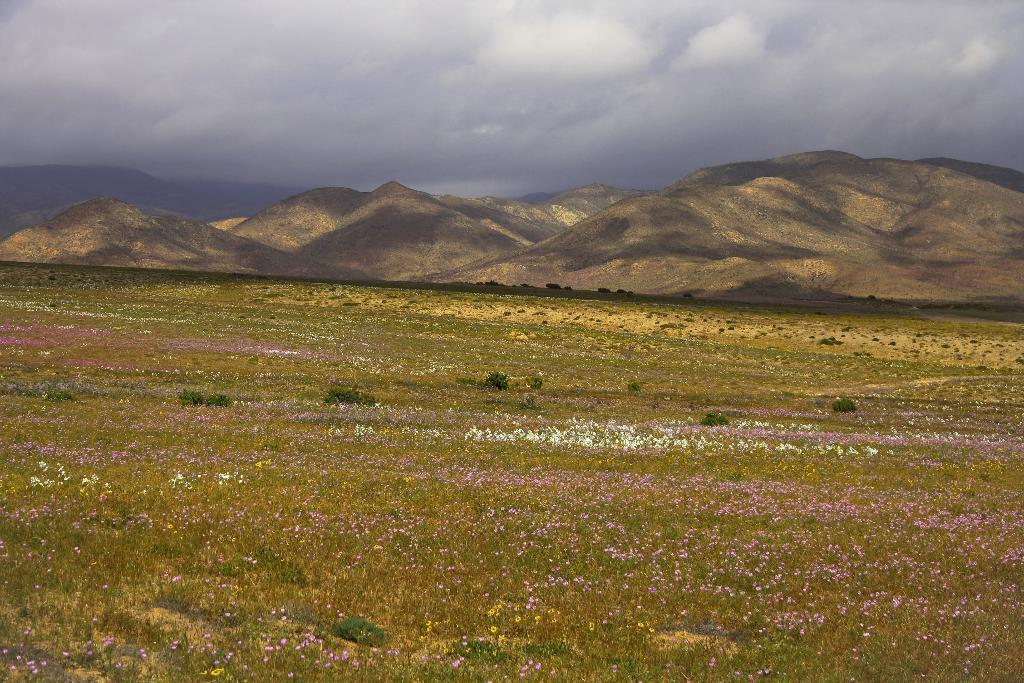What type of vegetation is on the ground in the image? There are plants on the ground in the image. What else can be seen on the ground in the image? There is grass on the ground in the image. What are the plants doing in the image? The plants have flowers in the image. What is visible in the background of the image? There are mountains in the background of the image. What is visible at the top of the image? The sky is visible at the top of the image. Can you tell me how many firemen are present in the image? There are no firemen present in the image. What type of magic is being performed by the man in the image? There is no man or magic present in the image. 